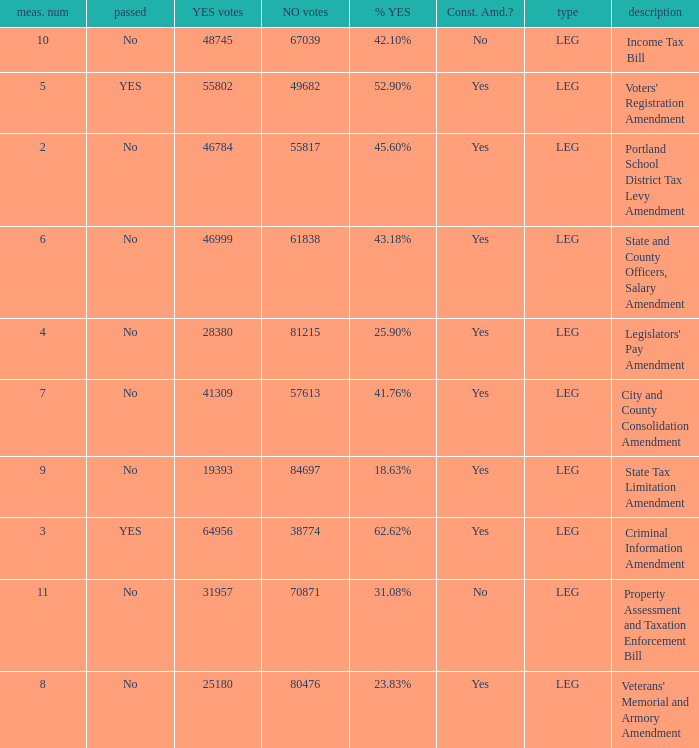HOw many no votes were there when there were 45.60% yes votes 55817.0. 